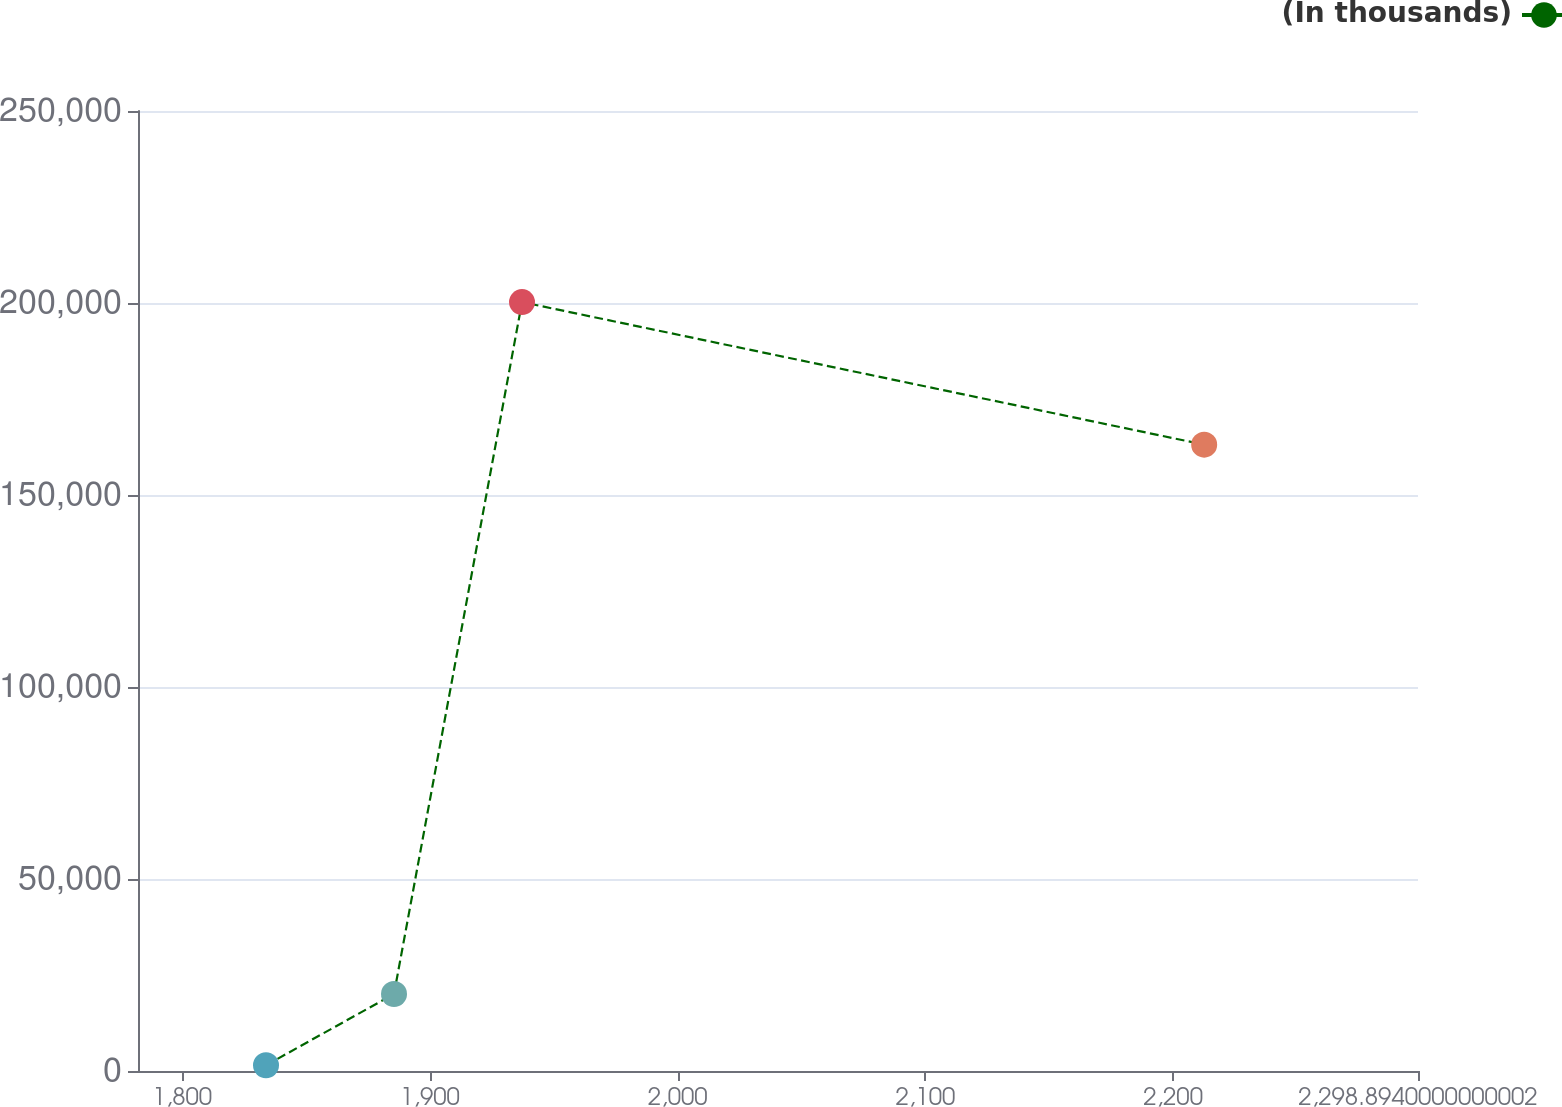Convert chart. <chart><loc_0><loc_0><loc_500><loc_500><line_chart><ecel><fcel>(In thousands)<nl><fcel>1833.81<fcel>1495.35<nl><fcel>1885.49<fcel>20054.5<nl><fcel>1937.17<fcel>200232<nl><fcel>2212.57<fcel>163114<nl><fcel>2350.57<fcel>181673<nl></chart> 